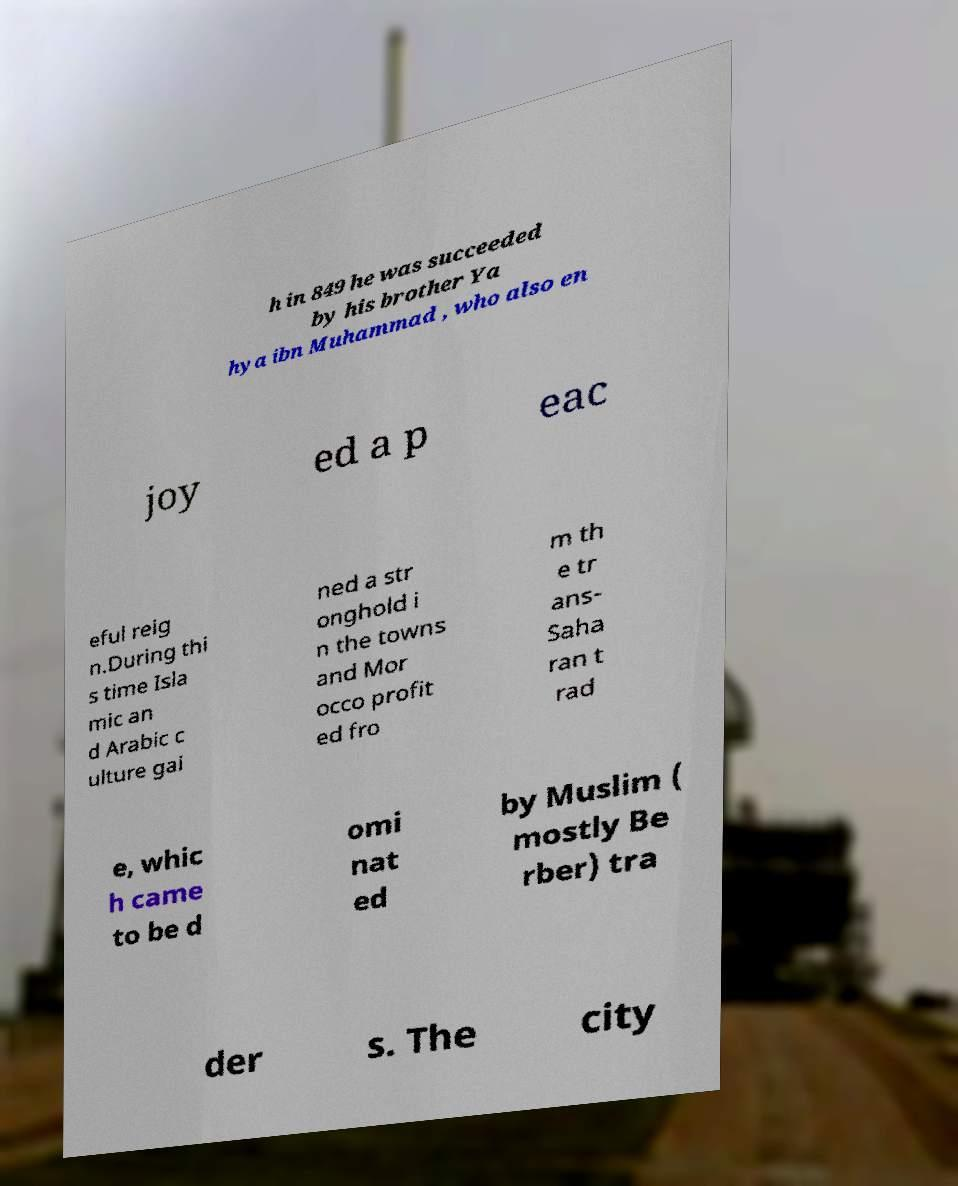Please identify and transcribe the text found in this image. h in 849 he was succeeded by his brother Ya hya ibn Muhammad , who also en joy ed a p eac eful reig n.During thi s time Isla mic an d Arabic c ulture gai ned a str onghold i n the towns and Mor occo profit ed fro m th e tr ans- Saha ran t rad e, whic h came to be d omi nat ed by Muslim ( mostly Be rber) tra der s. The city 